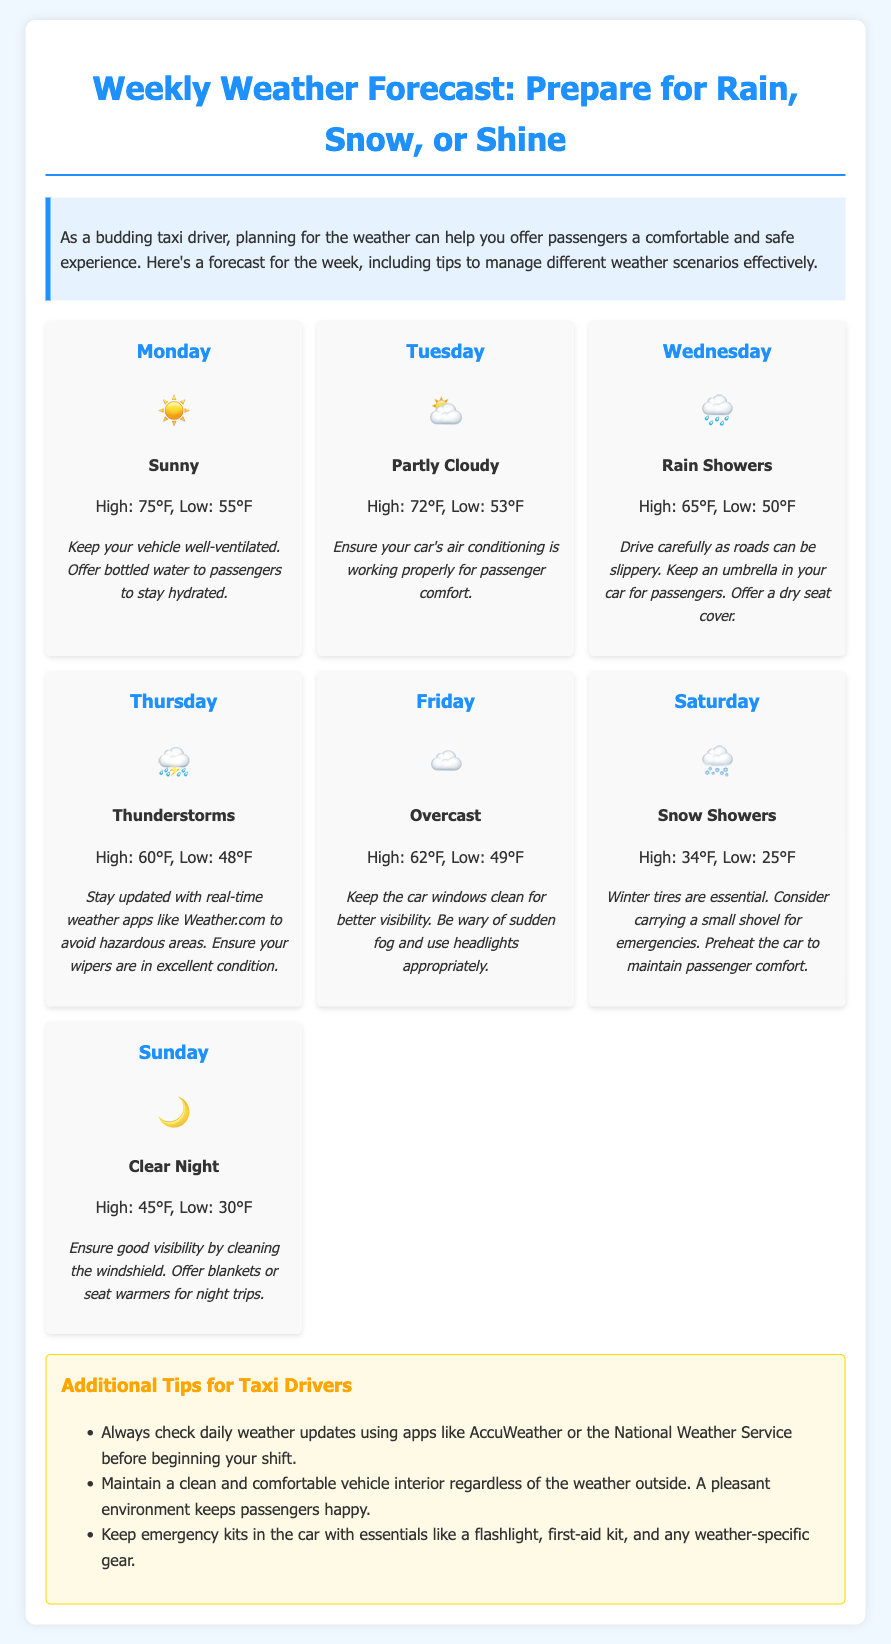What is the weather forecast for Monday? The weather forecast states that Monday will be sunny with a high of 75°F and a low of 55°F.
Answer: Sunny What type of weather can I expect on Thursday? The document indicates that Thursday will have thunderstorms, which can often impact driving conditions.
Answer: Thunderstorms What is the suggested tip for rainy weather on Wednesday? On Wednesday, it is advised to drive carefully due to slippery roads and to keep an umbrella for passengers.
Answer: Drive carefully What is the low temperature for Saturday? The forecast shows that the low temperature on Saturday is 25°F during snow showers.
Answer: 25°F Which day has a weather icon of a sun? The weather icon of a sun represents Monday, indicating sunny weather.
Answer: Monday What is an essential tip for snowy weather on Saturday? The document emphasizes that winter tires are essential for safe driving in snowy conditions.
Answer: Winter tires What should drivers do for passenger comfort during clear nights on Sunday? It is recommended to offer blankets or seat warmers to enhance passenger comfort during night trips.
Answer: Blankets or seat warmers What should drivers check before their shifts? Taxi drivers should check daily weather updates using weather apps before starting their shifts.
Answer: Weather updates What precaution is suggested for driving on Friday? For Friday, it's advised to keep car windows clean to ensure better visibility on overcast days.
Answer: Keep car windows clean 